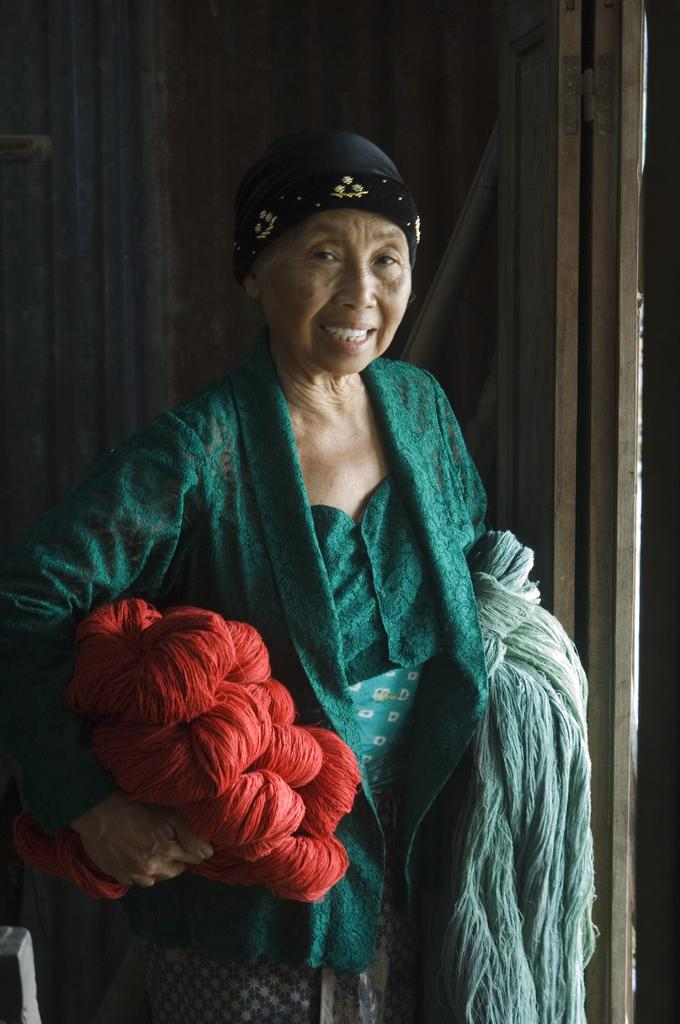Who is the main subject in the image? There is a woman in the image. What is the woman holding in her hands? The woman is holding clothes in her hands. What can be seen in the background of the image? There is a wooden wall in the background of the image. What type of bulb is hanging from the ceiling in the image? There is no bulb visible in the image; it only shows a woman holding clothes and a wooden wall in the background. 